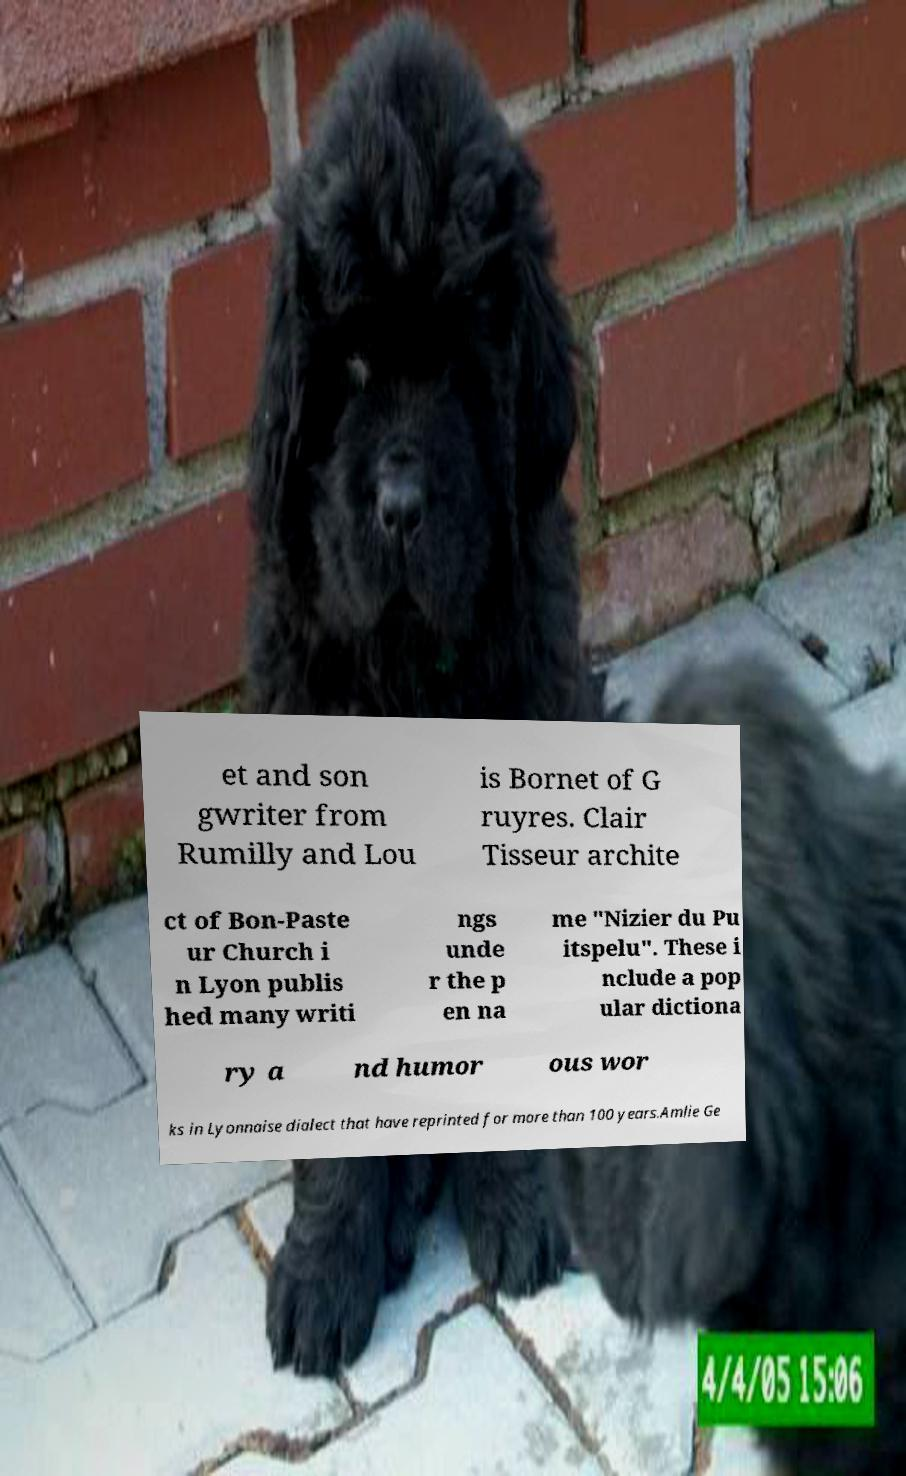Could you assist in decoding the text presented in this image and type it out clearly? et and son gwriter from Rumilly and Lou is Bornet of G ruyres. Clair Tisseur archite ct of Bon-Paste ur Church i n Lyon publis hed many writi ngs unde r the p en na me "Nizier du Pu itspelu". These i nclude a pop ular dictiona ry a nd humor ous wor ks in Lyonnaise dialect that have reprinted for more than 100 years.Amlie Ge 